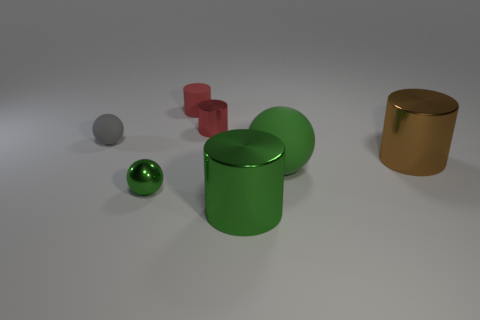What number of large metallic cylinders have the same color as the small metallic ball?
Keep it short and to the point. 1. Is the number of green matte objects greater than the number of big gray metallic cylinders?
Give a very brief answer. Yes. There is a sphere that is both on the left side of the green rubber ball and in front of the big brown shiny cylinder; what size is it?
Offer a very short reply. Small. Is the material of the tiny object in front of the gray ball the same as the cylinder that is in front of the large brown thing?
Provide a short and direct response. Yes. There is a rubber object that is the same size as the brown metal cylinder; what shape is it?
Ensure brevity in your answer.  Sphere. Are there fewer small green spheres than red metal blocks?
Keep it short and to the point. No. Is there a big shiny cylinder that is behind the big shiny cylinder in front of the large brown cylinder?
Make the answer very short. Yes. There is a rubber sphere that is left of the metal cylinder that is behind the brown shiny object; are there any small shiny objects to the left of it?
Offer a terse response. No. Is the shape of the big metallic object that is in front of the big brown metal cylinder the same as the rubber object behind the gray rubber sphere?
Offer a very short reply. Yes. There is a cylinder that is made of the same material as the big green ball; what color is it?
Keep it short and to the point. Red. 